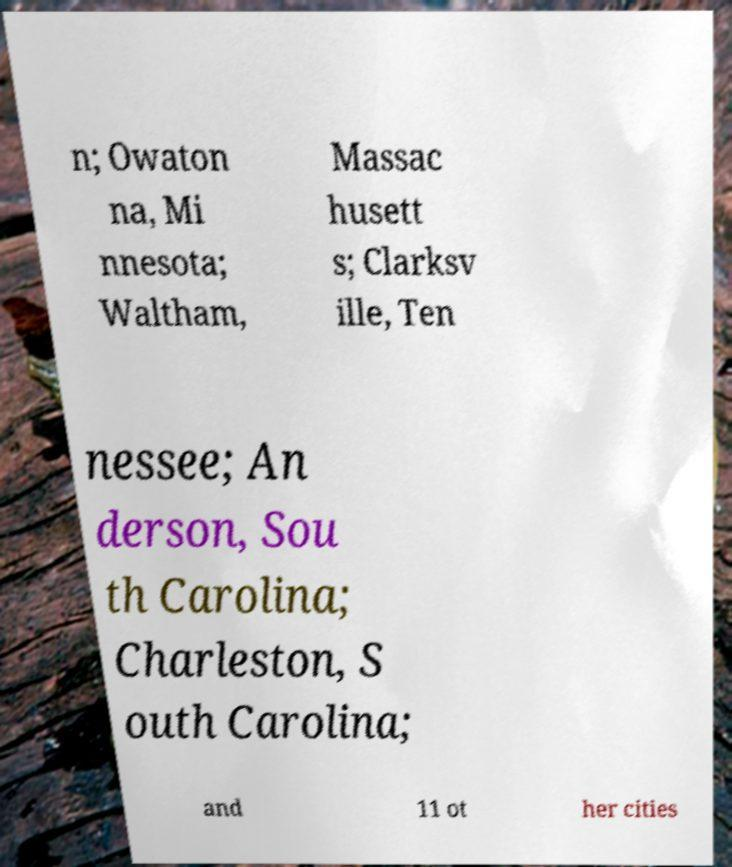Please identify and transcribe the text found in this image. n; Owaton na, Mi nnesota; Waltham, Massac husett s; Clarksv ille, Ten nessee; An derson, Sou th Carolina; Charleston, S outh Carolina; and 11 ot her cities 